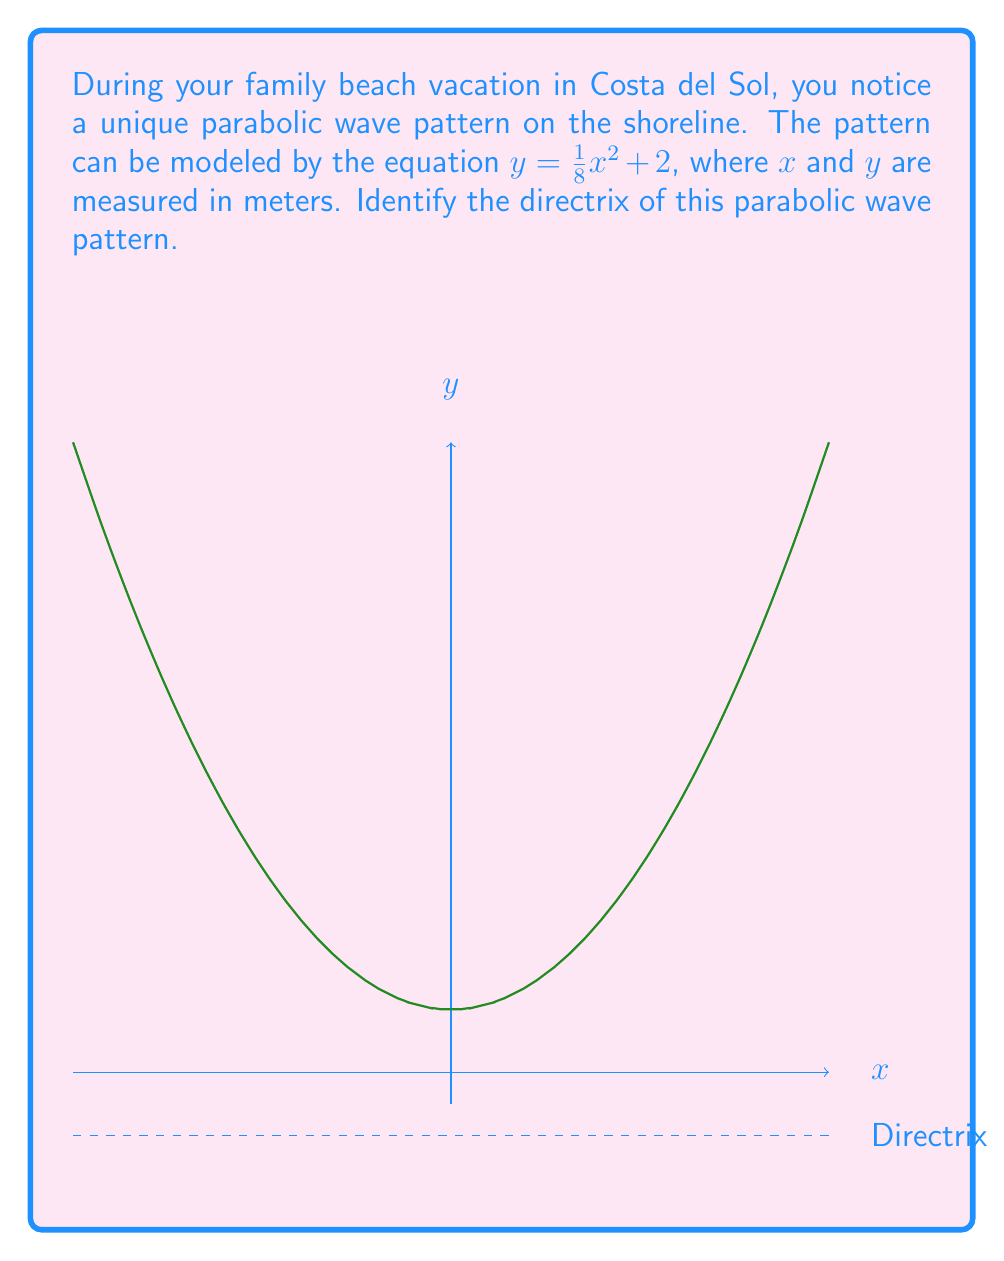Help me with this question. Let's approach this step-by-step:

1) The general form of a parabola with a vertical axis of symmetry is:
   $y = a(x-h)^2 + k$
   where $(h,k)$ is the vertex and $a$ determines the direction and width of the parabola.

2) Our equation is $y = \frac{1}{8}x^2 + 2$, which is already in the form $y = ax^2 + q$
   Here, $a = \frac{1}{8}$ and $q = 2$

3) The vertex of this parabola is $(0,2)$, as $h=0$ and $k=2$

4) For a parabola with equation $y = ax^2 + q$, the directrix is given by the equation:
   $y = q - \frac{1}{4a}$

5) Substituting our values:
   $y = 2 - \frac{1}{4(\frac{1}{8})}$
   $y = 2 - \frac{1}{\frac{1}{2}}$
   $y = 2 - 2 = 0$

Therefore, the directrix of the parabolic wave pattern is the line $y = 0$, which corresponds to the x-axis in our coordinate system.
Answer: $y = 0$ 